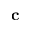<formula> <loc_0><loc_0><loc_500><loc_500>c</formula> 